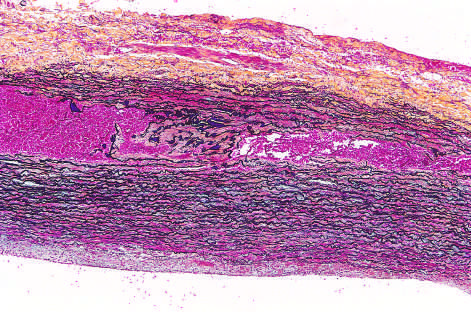re aortic elastic layers black?
Answer the question using a single word or phrase. Yes 